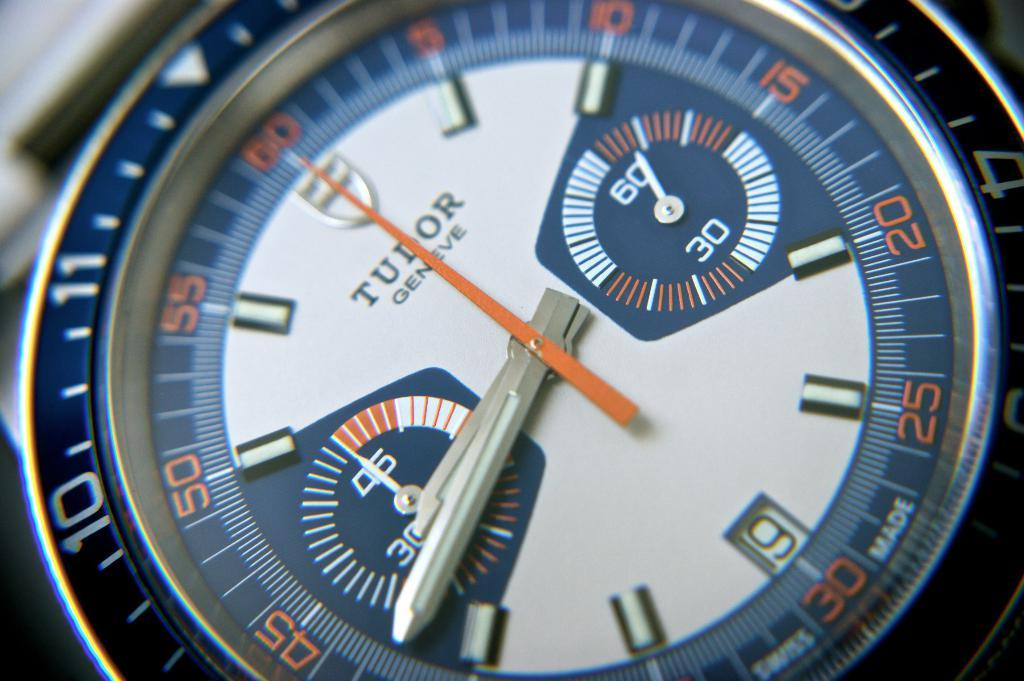Provide a one-sentence caption for the provided image. A blue, orange and white, Tudor Geneve , watch shows the time as 8:42. 